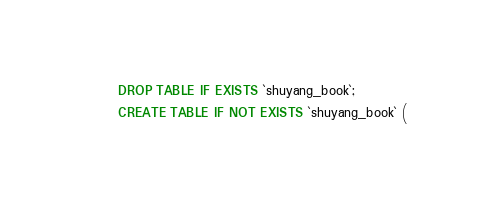Convert code to text. <code><loc_0><loc_0><loc_500><loc_500><_SQL_>DROP TABLE IF EXISTS `shuyang_book`;
CREATE TABLE IF NOT EXISTS `shuyang_book` (</code> 